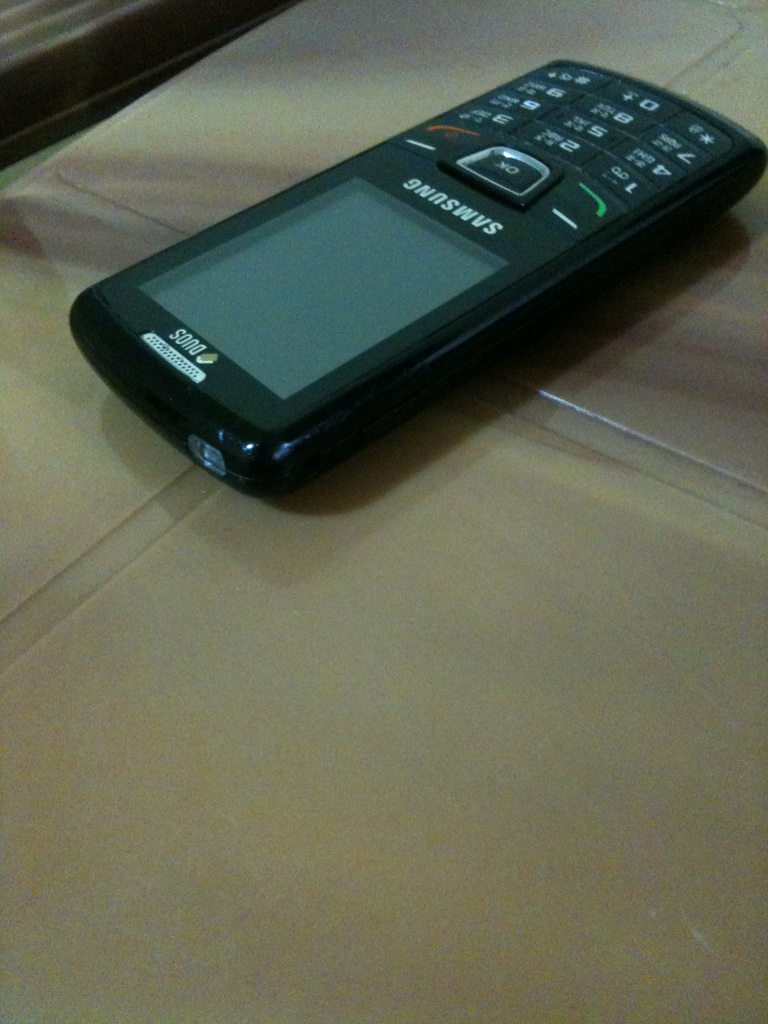Why might someone prefer this type of phone today? Some people might prefer this type of phone because of its simplicity, durability, longer battery life, and ease of use due to physical buttons. It could also be favored for the reduced distractions and lower cost compared to modern smartphones. 